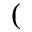<formula> <loc_0><loc_0><loc_500><loc_500>(</formula> 